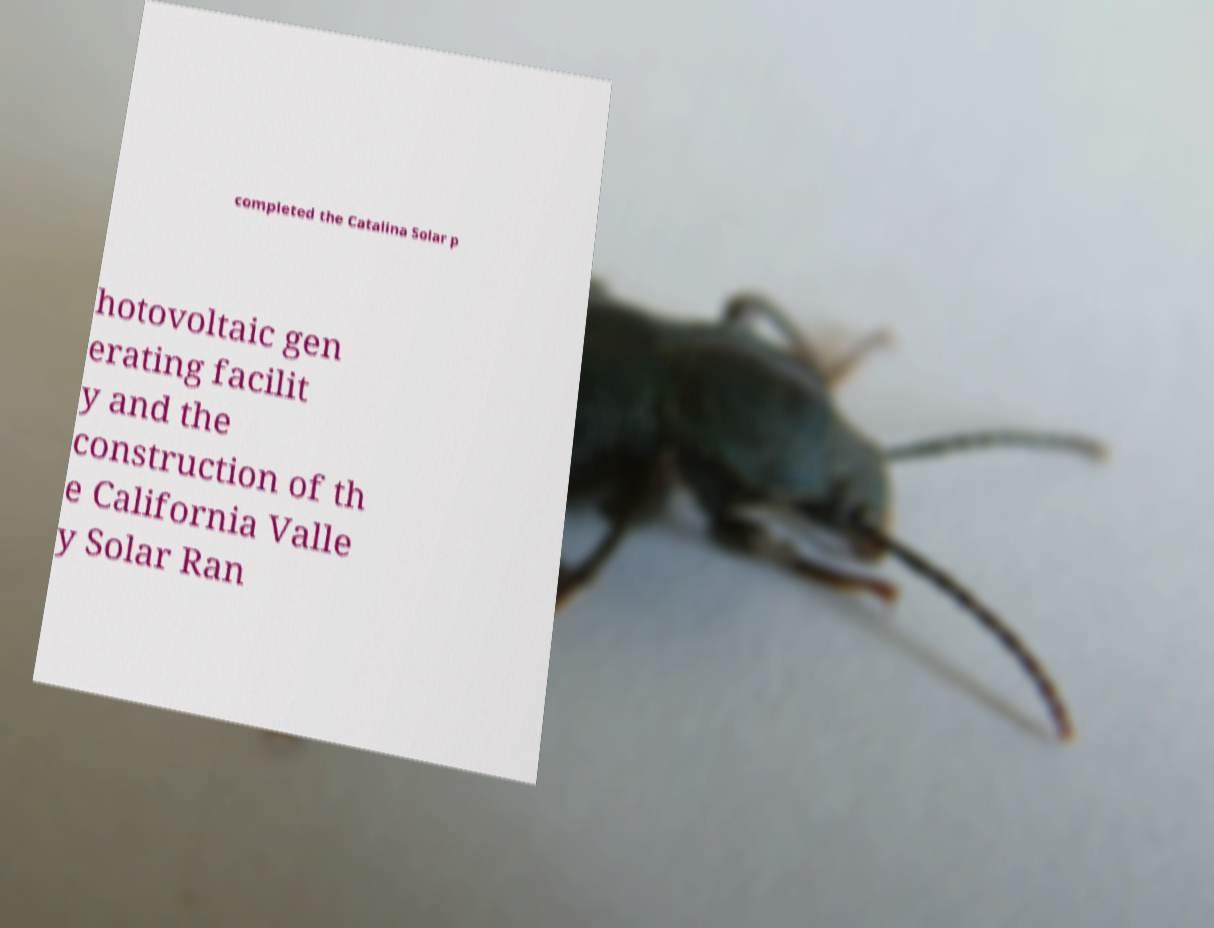Can you accurately transcribe the text from the provided image for me? completed the Catalina Solar p hotovoltaic gen erating facilit y and the construction of th e California Valle y Solar Ran 